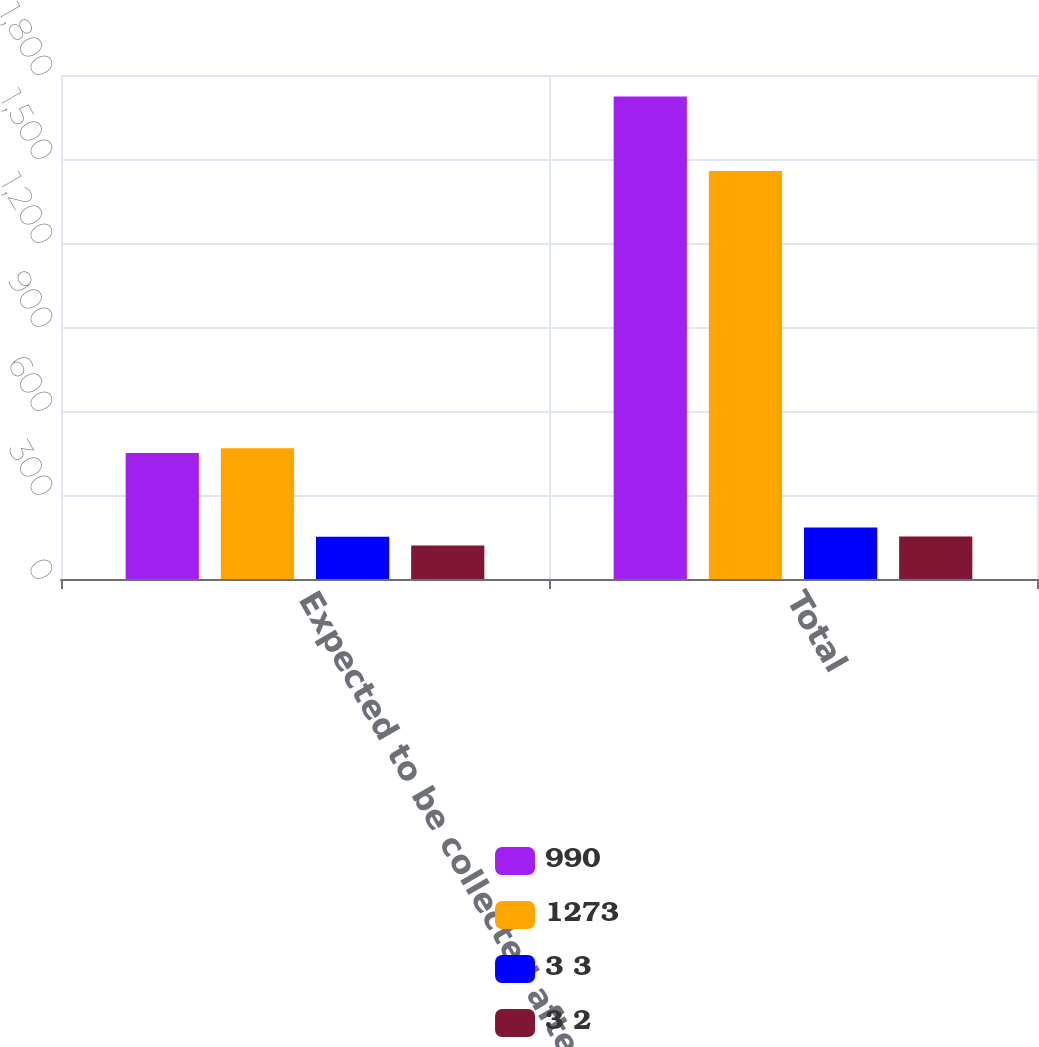<chart> <loc_0><loc_0><loc_500><loc_500><stacked_bar_chart><ecel><fcel>Expected to be collected after<fcel>Total<nl><fcel>990<fcel>450<fcel>1723<nl><fcel>1273<fcel>467<fcel>1457<nl><fcel>3 3<fcel>151<fcel>184<nl><fcel>3 2<fcel>120<fcel>152<nl></chart> 